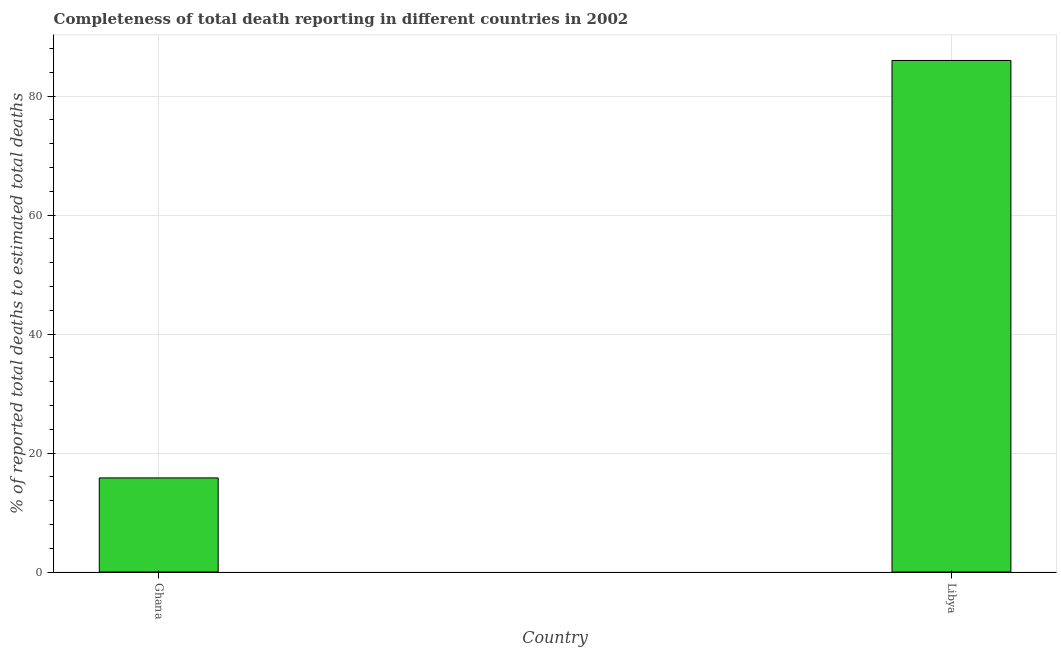What is the title of the graph?
Keep it short and to the point. Completeness of total death reporting in different countries in 2002. What is the label or title of the X-axis?
Provide a succinct answer. Country. What is the label or title of the Y-axis?
Give a very brief answer. % of reported total deaths to estimated total deaths. What is the completeness of total death reports in Ghana?
Give a very brief answer. 15.82. Across all countries, what is the maximum completeness of total death reports?
Keep it short and to the point. 85.99. Across all countries, what is the minimum completeness of total death reports?
Your answer should be very brief. 15.82. In which country was the completeness of total death reports maximum?
Your response must be concise. Libya. What is the sum of the completeness of total death reports?
Make the answer very short. 101.81. What is the difference between the completeness of total death reports in Ghana and Libya?
Offer a terse response. -70.17. What is the average completeness of total death reports per country?
Your answer should be very brief. 50.9. What is the median completeness of total death reports?
Give a very brief answer. 50.9. In how many countries, is the completeness of total death reports greater than 84 %?
Your answer should be very brief. 1. What is the ratio of the completeness of total death reports in Ghana to that in Libya?
Give a very brief answer. 0.18. Is the completeness of total death reports in Ghana less than that in Libya?
Keep it short and to the point. Yes. In how many countries, is the completeness of total death reports greater than the average completeness of total death reports taken over all countries?
Make the answer very short. 1. How many bars are there?
Offer a terse response. 2. How many countries are there in the graph?
Your answer should be very brief. 2. What is the difference between two consecutive major ticks on the Y-axis?
Provide a succinct answer. 20. Are the values on the major ticks of Y-axis written in scientific E-notation?
Ensure brevity in your answer.  No. What is the % of reported total deaths to estimated total deaths in Ghana?
Provide a short and direct response. 15.82. What is the % of reported total deaths to estimated total deaths of Libya?
Ensure brevity in your answer.  85.99. What is the difference between the % of reported total deaths to estimated total deaths in Ghana and Libya?
Your answer should be very brief. -70.18. What is the ratio of the % of reported total deaths to estimated total deaths in Ghana to that in Libya?
Your answer should be compact. 0.18. 